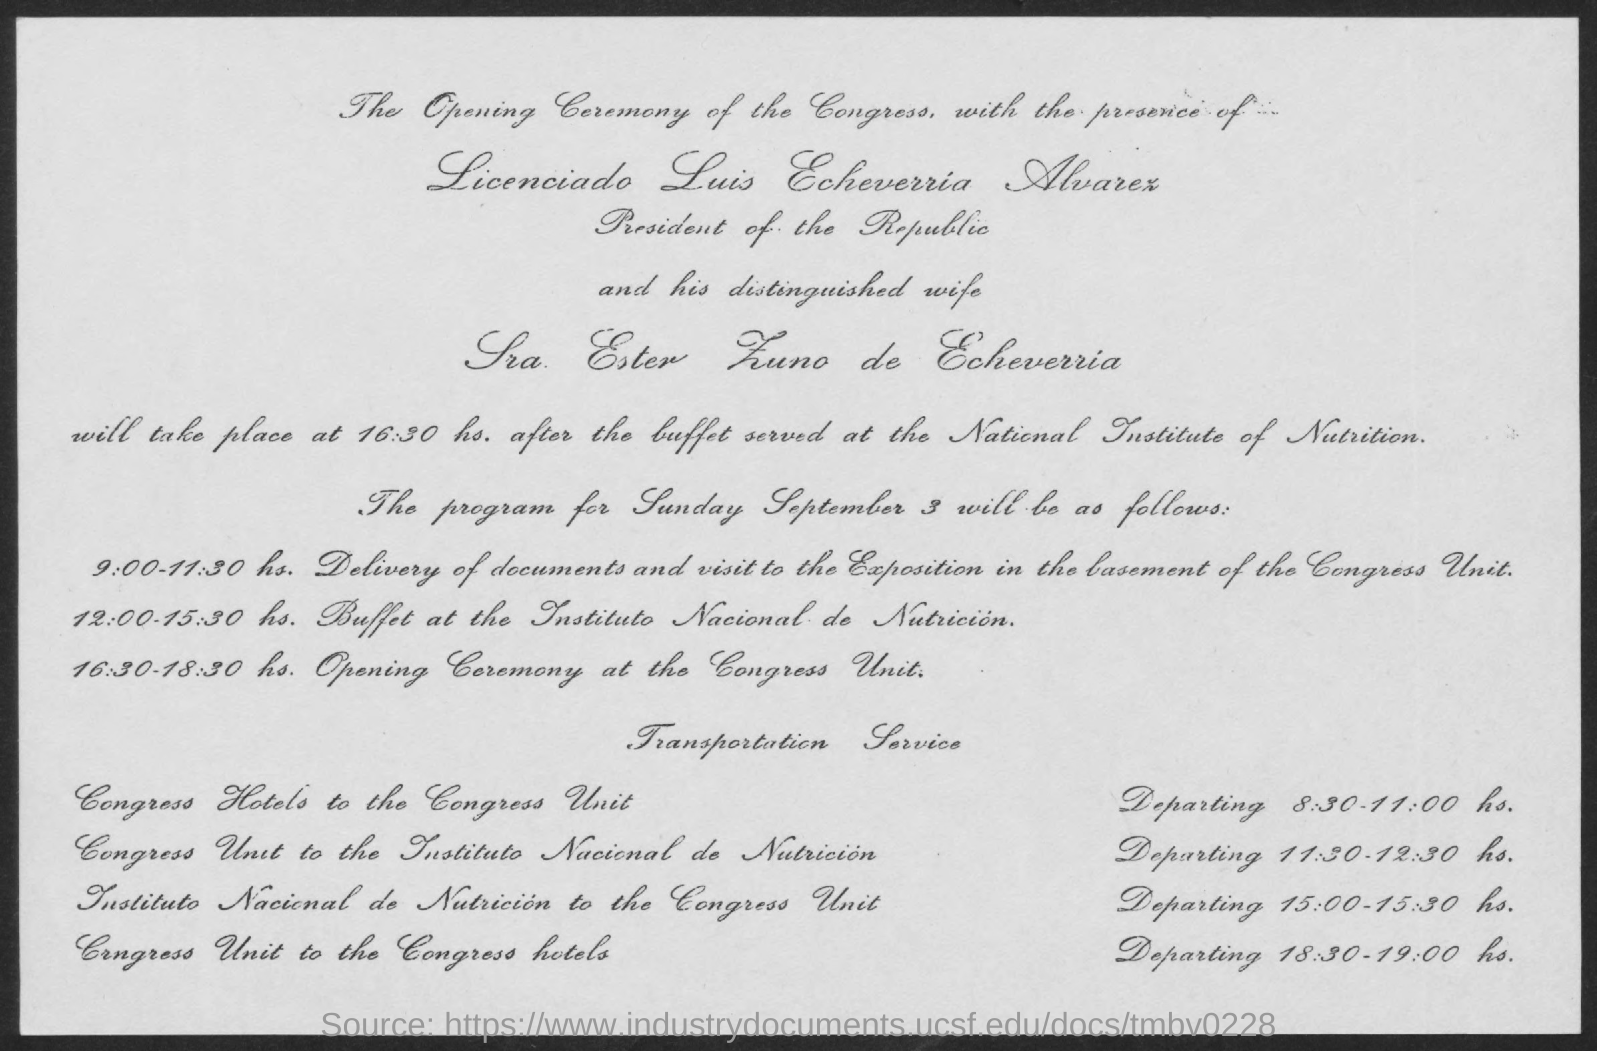Specify some key components in this picture. The President of the Republic is Licenciado Luis Echeverria Alvarez. 